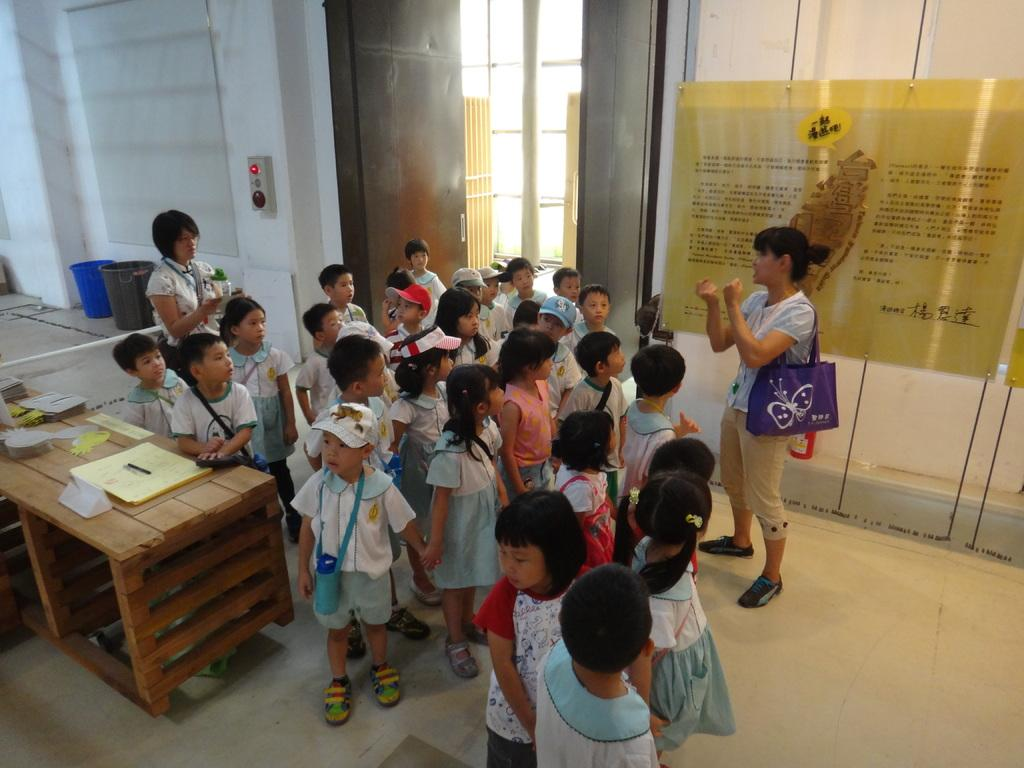What type of structure can be seen in the image? There is a wall in the image. What is attached to the wall in the image? There is a poster attached to the wall in the image. What are the people in the image doing? The people standing on the floor in the image are not performing any specific action. What type of furniture is present in the image? There is a table in the image. What might be used for disposing of waste in the image? There are dustbins in the image. What type of wall can be seen in the image that is filled with hate? There is no indication of hate in the image; the wall and poster are neutral subjects. What type of support can be seen in the image? There is no specific support structure present in the image; the wall and poster are the main subjects. 